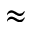<formula> <loc_0><loc_0><loc_500><loc_500>\approx</formula> 